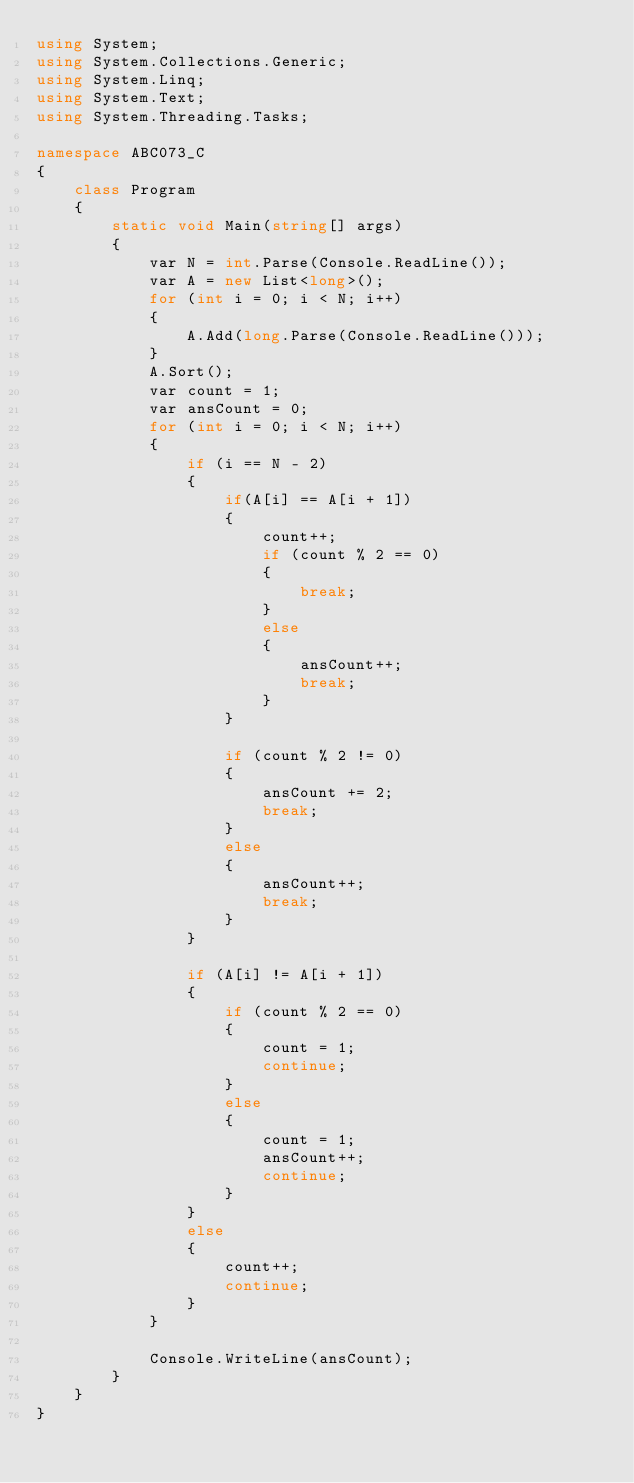<code> <loc_0><loc_0><loc_500><loc_500><_C#_>using System;
using System.Collections.Generic;
using System.Linq;
using System.Text;
using System.Threading.Tasks;

namespace ABC073_C
{
    class Program
    {
        static void Main(string[] args)
        {
            var N = int.Parse(Console.ReadLine());
            var A = new List<long>();
            for (int i = 0; i < N; i++)
            {
                A.Add(long.Parse(Console.ReadLine()));
            }
            A.Sort();
            var count = 1;
            var ansCount = 0;
            for (int i = 0; i < N; i++)
            {
                if (i == N - 2)
                {
                    if(A[i] == A[i + 1])
                    {
                        count++;
                        if (count % 2 == 0)
                        {
                            break;
                        }
                        else
                        {
                            ansCount++;
                            break;
                        }
                    }

                    if (count % 2 != 0)
                    {
                        ansCount += 2;
                        break;
                    }
                    else
                    {
                        ansCount++;
                        break;
                    }
                }

                if (A[i] != A[i + 1])
                {
                    if (count % 2 == 0)
                    {
                        count = 1;
                        continue;
                    }
                    else
                    {
                        count = 1;
                        ansCount++;
                        continue;
                    }
                }
                else
                {
                    count++;
                    continue;
                }
            }

            Console.WriteLine(ansCount);
        }
    }
}
</code> 